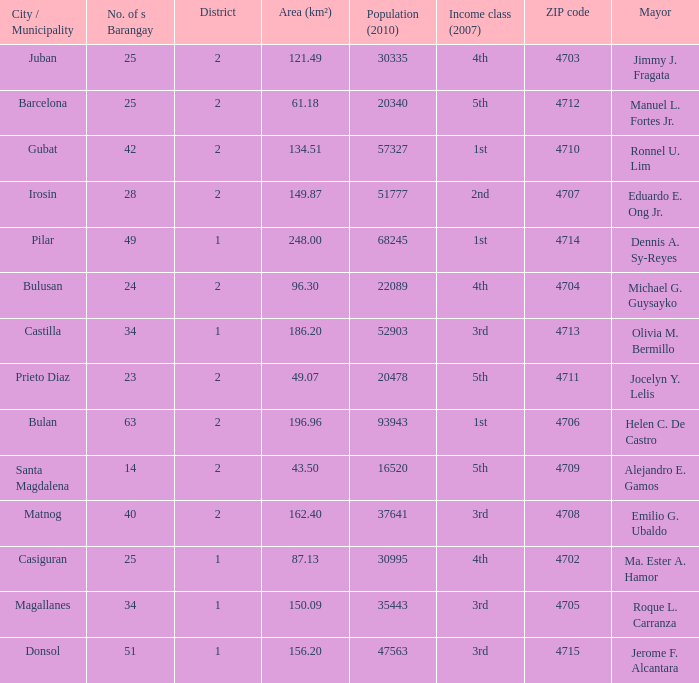What are all the profits elegance (2007) in which mayor is ma. Ester a. Hamor 4th. 